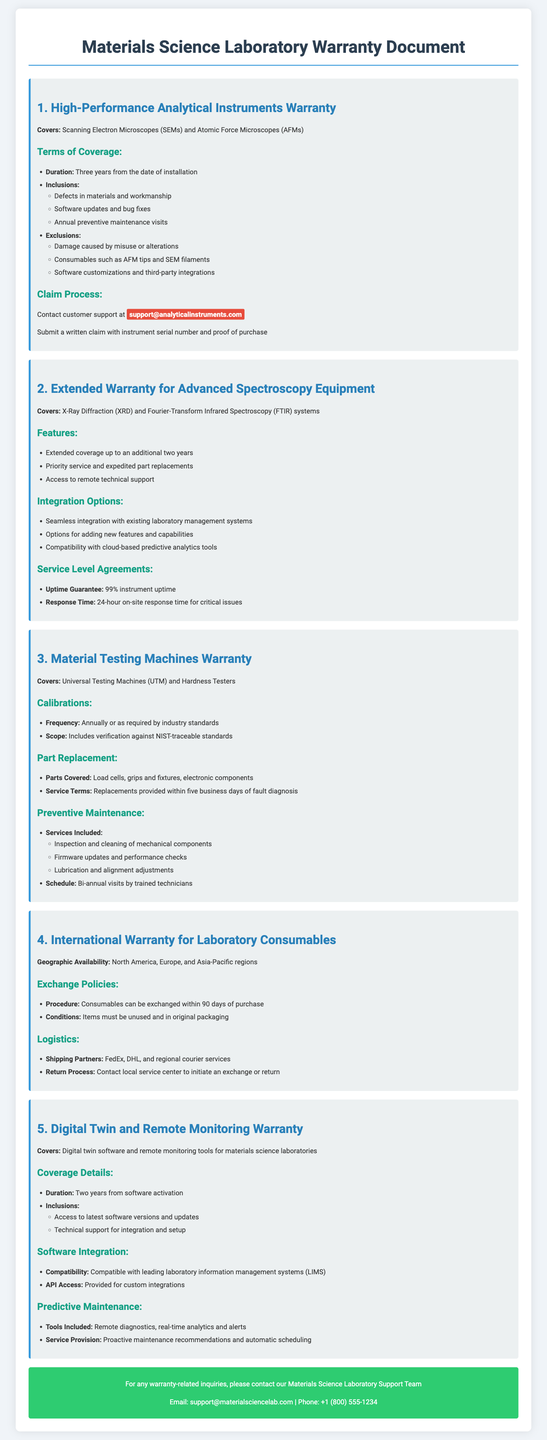What is the coverage duration for SEMs and AFMs? The coverage is for three years from the date of installation.
Answer: Three years What third-party integrations are excluded from the warranty for high-performance analytical instruments? Exclusions include software customizations and third-party integrations.
Answer: Software customizations and third-party integrations What is the frequency of calibrations for material testing machines? Calibrations are required annually or as per industry standards.
Answer: Annually What is the procedure for exchanging laboratory consumables? The procedure requires consumables to be exchanged within 90 days of purchase.
Answer: Within 90 days of purchase What is the uptime guarantee provided for advanced spectroscopy equipment? The uptime guarantee is set at 99%.
Answer: 99% What type of support is provided under the Digital Twin warranty? Technical support for integration and setup is included.
Answer: Technical support for integration and setup What is the response time for critical issues under the SLA for spectroscopy equipment? The response time is within 24 hours on-site for critical issues.
Answer: 24 hours What are the shipping partners for international warranty logistics? Shipping partners include FedEx, DHL, and regional courier services.
Answer: FedEx, DHL, and regional courier services What tools are included in predictive maintenance for remote monitoring? The tools included are remote diagnostics, real-time analytics and alerts.
Answer: Remote diagnostics, real-time analytics and alerts 